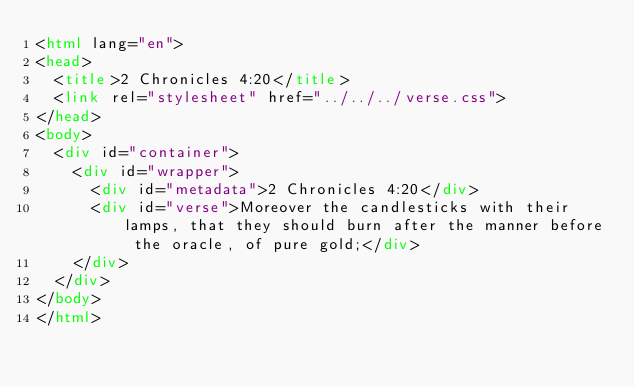Convert code to text. <code><loc_0><loc_0><loc_500><loc_500><_HTML_><html lang="en">
<head>
  <title>2 Chronicles 4:20</title>
  <link rel="stylesheet" href="../../../verse.css">
</head>
<body>
  <div id="container">
    <div id="wrapper">
      <div id="metadata">2 Chronicles 4:20</div>
      <div id="verse">Moreover the candlesticks with their lamps, that they should burn after the manner before the oracle, of pure gold;</div>
    </div>
  </div>
</body>
</html></code> 